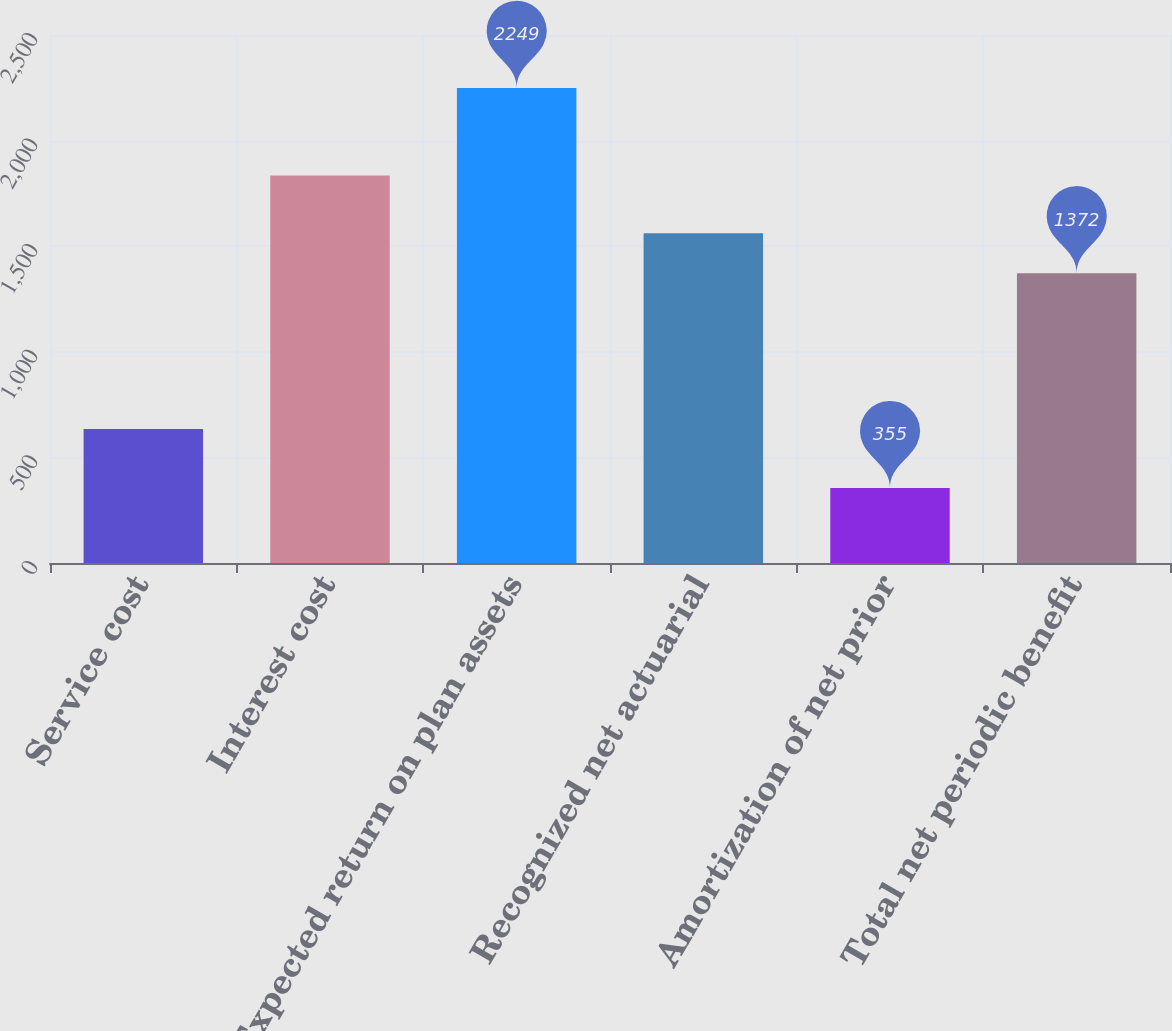Convert chart. <chart><loc_0><loc_0><loc_500><loc_500><bar_chart><fcel>Service cost<fcel>Interest cost<fcel>Expected return on plan assets<fcel>Recognized net actuarial<fcel>Amortization of net prior<fcel>Total net periodic benefit<nl><fcel>635<fcel>1835<fcel>2249<fcel>1561.4<fcel>355<fcel>1372<nl></chart> 